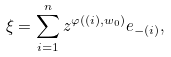Convert formula to latex. <formula><loc_0><loc_0><loc_500><loc_500>\xi = \sum _ { i = 1 } ^ { n } z ^ { \varphi ( ( i ) , w _ { 0 } ) } e _ { - ( i ) } ,</formula> 